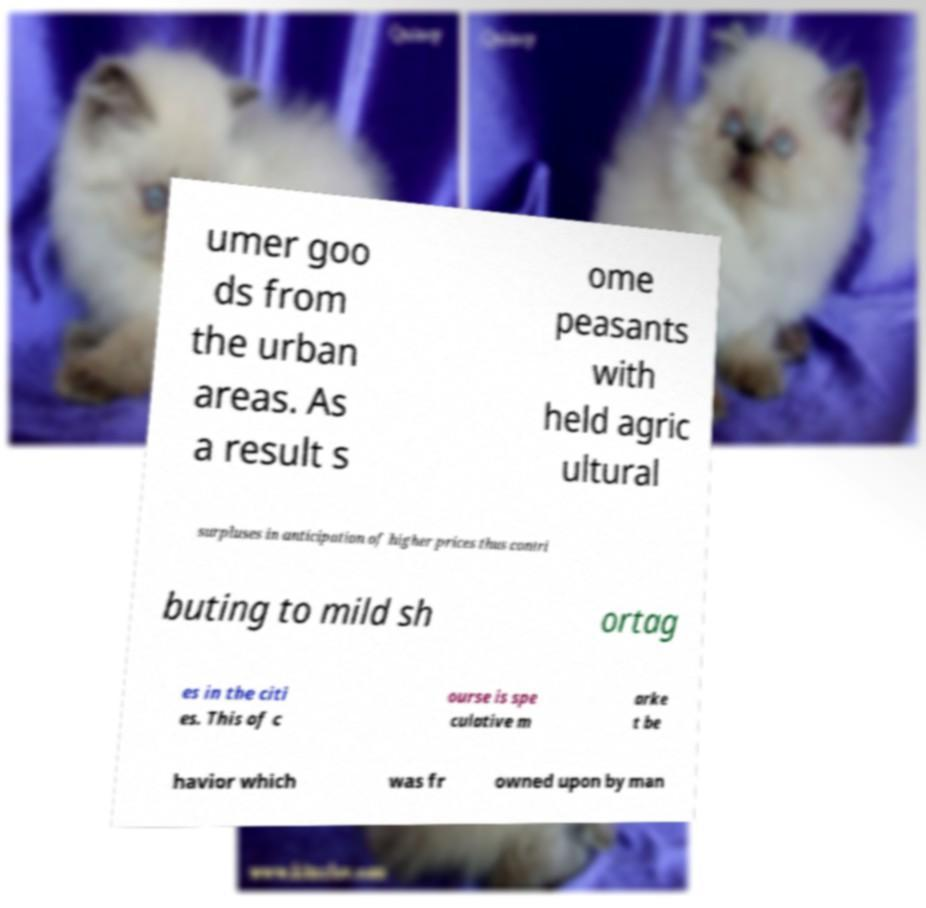Can you accurately transcribe the text from the provided image for me? umer goo ds from the urban areas. As a result s ome peasants with held agric ultural surpluses in anticipation of higher prices thus contri buting to mild sh ortag es in the citi es. This of c ourse is spe culative m arke t be havior which was fr owned upon by man 